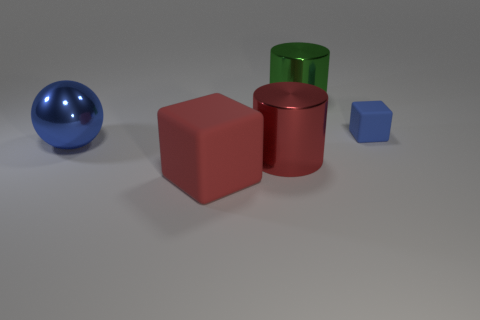Add 3 blue blocks. How many blue blocks exist? 4 Add 2 large cyan metallic objects. How many objects exist? 7 Subtract all red cylinders. How many cylinders are left? 1 Subtract 0 green balls. How many objects are left? 5 Subtract all blocks. How many objects are left? 3 Subtract 1 blocks. How many blocks are left? 1 Subtract all gray cylinders. Subtract all cyan balls. How many cylinders are left? 2 Subtract all purple cubes. How many gray cylinders are left? 0 Subtract all red metal cylinders. Subtract all green things. How many objects are left? 3 Add 1 large green things. How many large green things are left? 2 